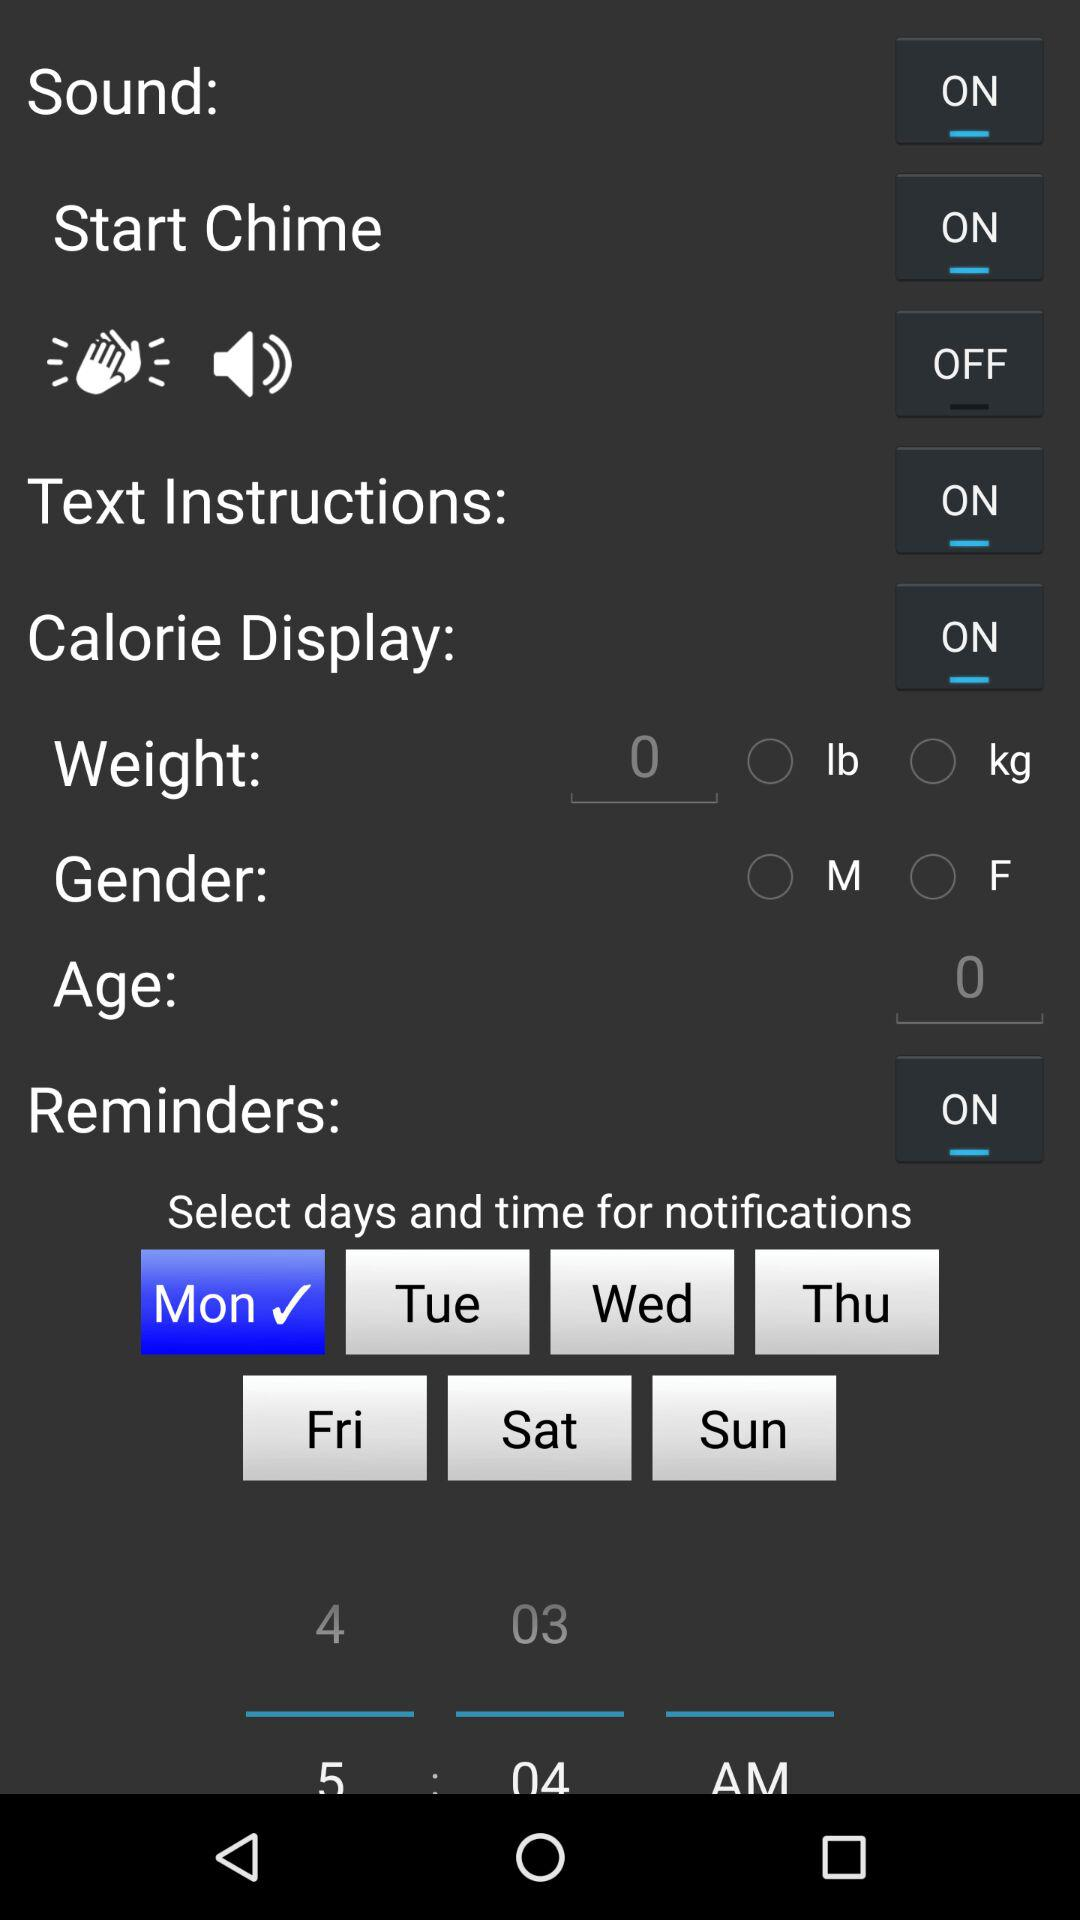What is the status of "Sound"? The status of "Sound" is "on". 